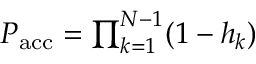<formula> <loc_0><loc_0><loc_500><loc_500>\begin{array} { r } { P _ { a c c } = \prod _ { k = 1 } ^ { N - 1 } ( 1 - h _ { k } ) } \end{array}</formula> 